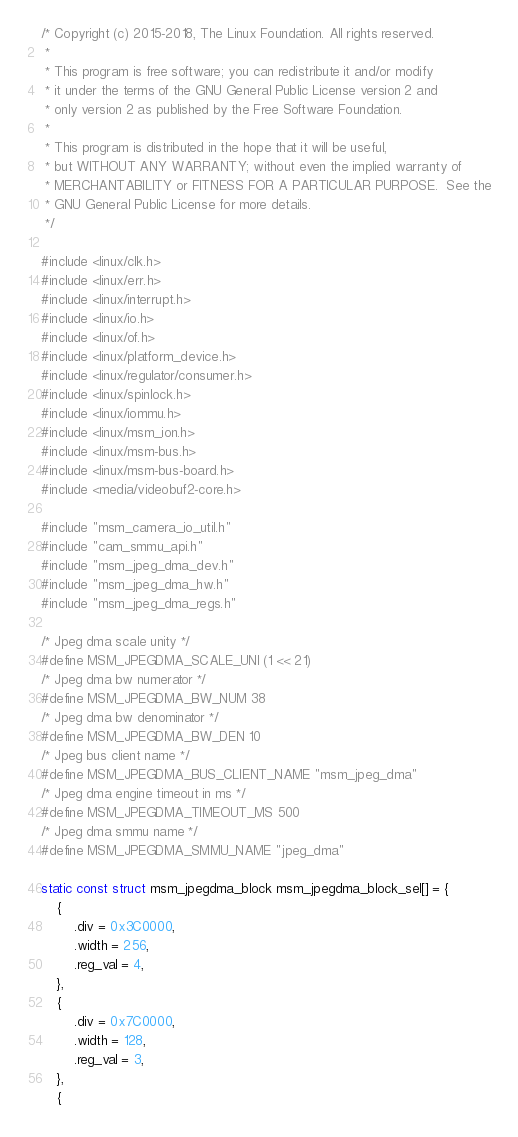Convert code to text. <code><loc_0><loc_0><loc_500><loc_500><_C_>/* Copyright (c) 2015-2018, The Linux Foundation. All rights reserved.
 *
 * This program is free software; you can redistribute it and/or modify
 * it under the terms of the GNU General Public License version 2 and
 * only version 2 as published by the Free Software Foundation.
 *
 * This program is distributed in the hope that it will be useful,
 * but WITHOUT ANY WARRANTY; without even the implied warranty of
 * MERCHANTABILITY or FITNESS FOR A PARTICULAR PURPOSE.  See the
 * GNU General Public License for more details.
 */

#include <linux/clk.h>
#include <linux/err.h>
#include <linux/interrupt.h>
#include <linux/io.h>
#include <linux/of.h>
#include <linux/platform_device.h>
#include <linux/regulator/consumer.h>
#include <linux/spinlock.h>
#include <linux/iommu.h>
#include <linux/msm_ion.h>
#include <linux/msm-bus.h>
#include <linux/msm-bus-board.h>
#include <media/videobuf2-core.h>

#include "msm_camera_io_util.h"
#include "cam_smmu_api.h"
#include "msm_jpeg_dma_dev.h"
#include "msm_jpeg_dma_hw.h"
#include "msm_jpeg_dma_regs.h"

/* Jpeg dma scale unity */
#define MSM_JPEGDMA_SCALE_UNI (1 << 21)
/* Jpeg dma bw numerator */
#define MSM_JPEGDMA_BW_NUM 38
/* Jpeg dma bw denominator */
#define MSM_JPEGDMA_BW_DEN 10
/* Jpeg bus client name */
#define MSM_JPEGDMA_BUS_CLIENT_NAME "msm_jpeg_dma"
/* Jpeg dma engine timeout in ms */
#define MSM_JPEGDMA_TIMEOUT_MS 500
/* Jpeg dma smmu name */
#define MSM_JPEGDMA_SMMU_NAME "jpeg_dma"

static const struct msm_jpegdma_block msm_jpegdma_block_sel[] = {
	{
		.div = 0x3C0000,
		.width = 256,
		.reg_val = 4,
	},
	{
		.div = 0x7C0000,
		.width = 128,
		.reg_val = 3,
	},
	{</code> 